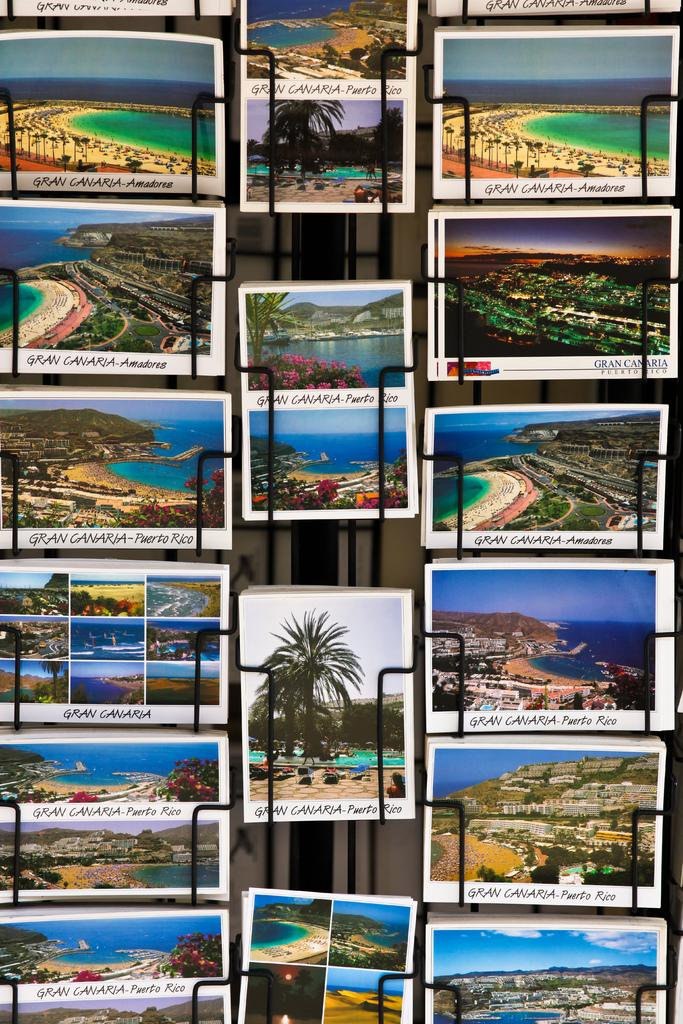What type of images are present in the collage? The image contains collage images. What elements can be found in the collage images? Buildings, trees, seas, text, plants, flowers, and lights are depicted in the collage images. Can you describe the scenarios depicted in the collage images? The collage images contain various scenarios, but specific details are not provided in the facts. What type of vegetation is depicted in the collage images? Trees and plants are depicted in the collage images. Where is the dock located in the collage images? There is no dock present in the collage images. How do the flowers roll in the collage images? The flowers do not roll in the collage images; they are depicted as stationary on the plants. 